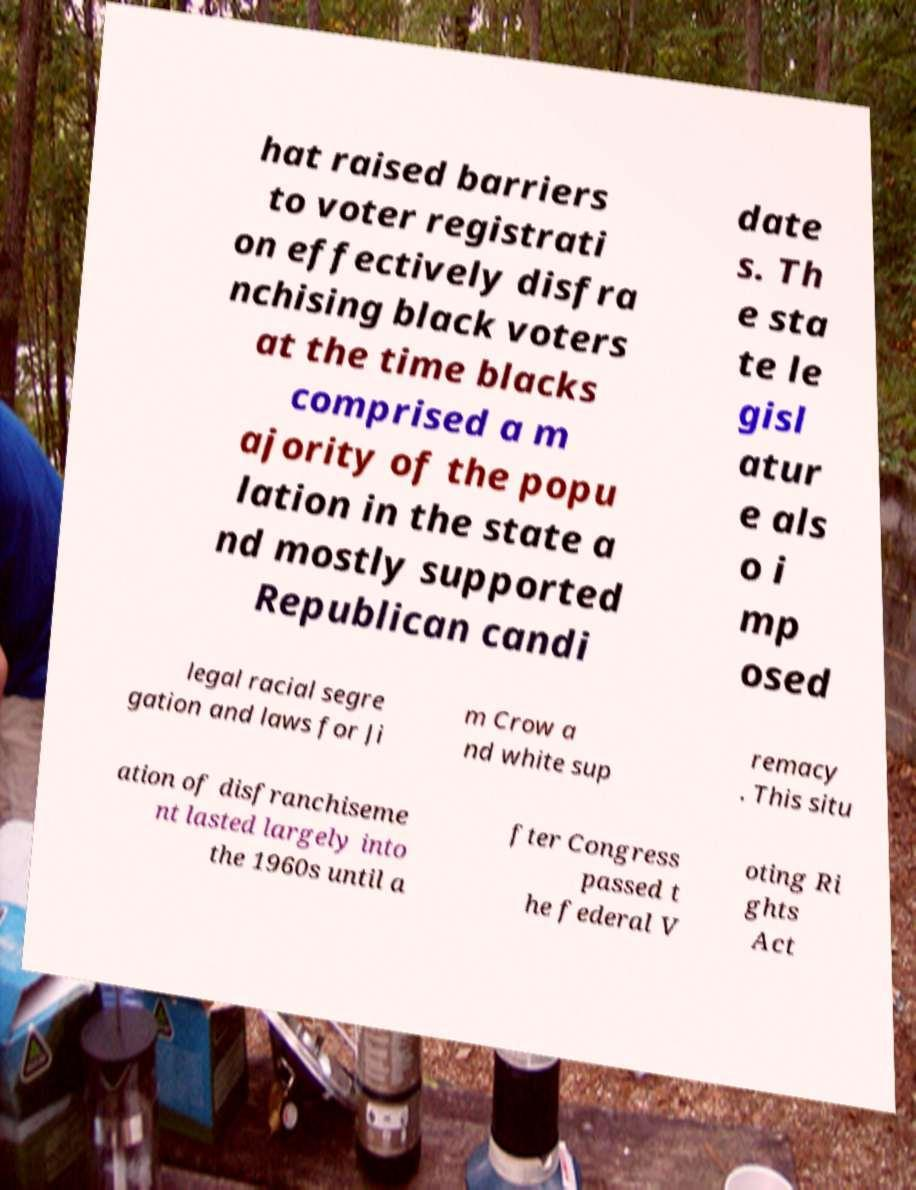Could you extract and type out the text from this image? hat raised barriers to voter registrati on effectively disfra nchising black voters at the time blacks comprised a m ajority of the popu lation in the state a nd mostly supported Republican candi date s. Th e sta te le gisl atur e als o i mp osed legal racial segre gation and laws for Ji m Crow a nd white sup remacy . This situ ation of disfranchiseme nt lasted largely into the 1960s until a fter Congress passed t he federal V oting Ri ghts Act 